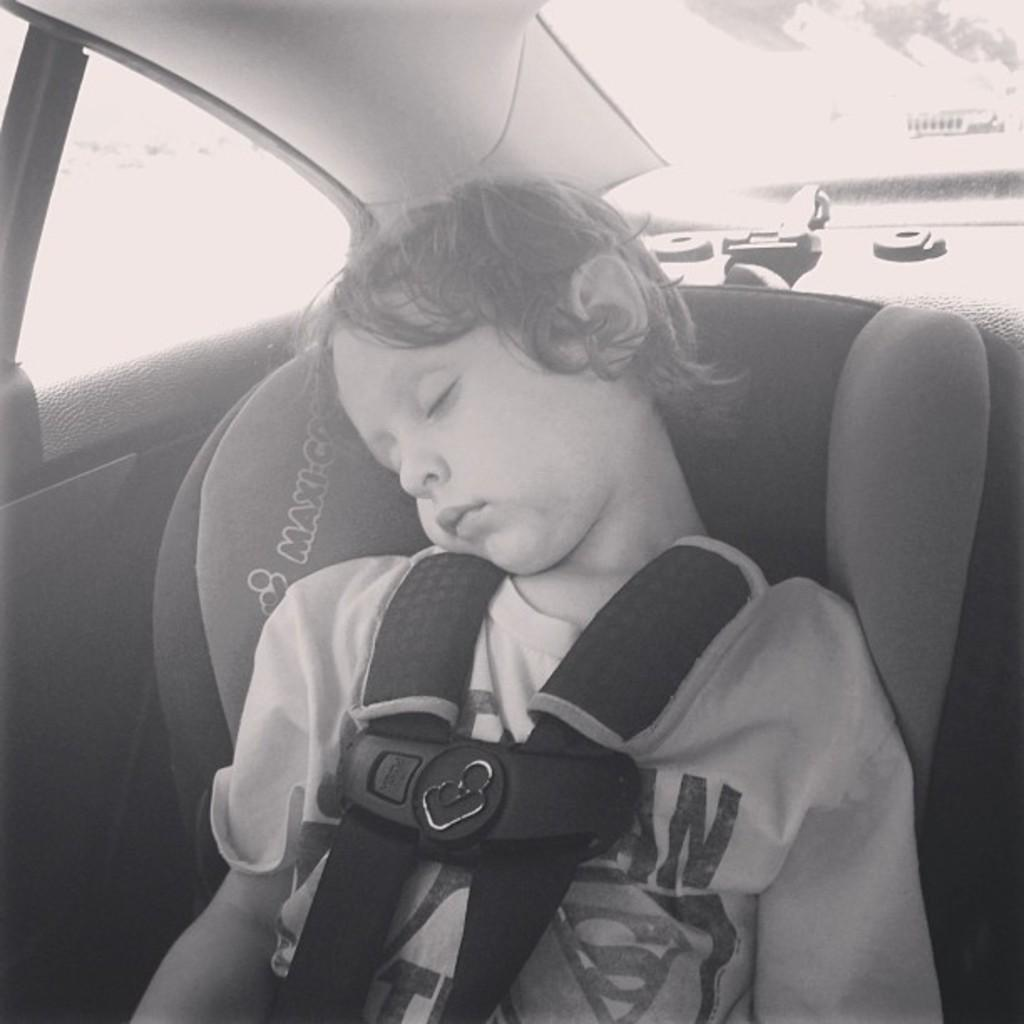Who is present in the image? There is a boy in the image. What is the boy doing in the image? The boy is sleeping in the image. Where is the boy located in the image? The boy is inside a car in the image. What type of ghost can be seen interacting with the boy in the image? There is no ghost present in the image; the boy is sleeping inside a car. What is the size of the light source in the image? There is no mention of a light source in the image, so we cannot determine its size. 